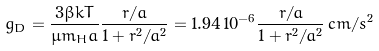<formula> <loc_0><loc_0><loc_500><loc_500>g _ { D } = \frac { 3 \beta k T } { \mu m _ { H } a } \frac { r / a } { 1 + r ^ { 2 } / a ^ { 2 } } = 1 . 9 4 \, 1 0 ^ { - 6 } \frac { r / a } { 1 + r ^ { 2 } / a ^ { 2 } } \, c m / s ^ { 2 }</formula> 